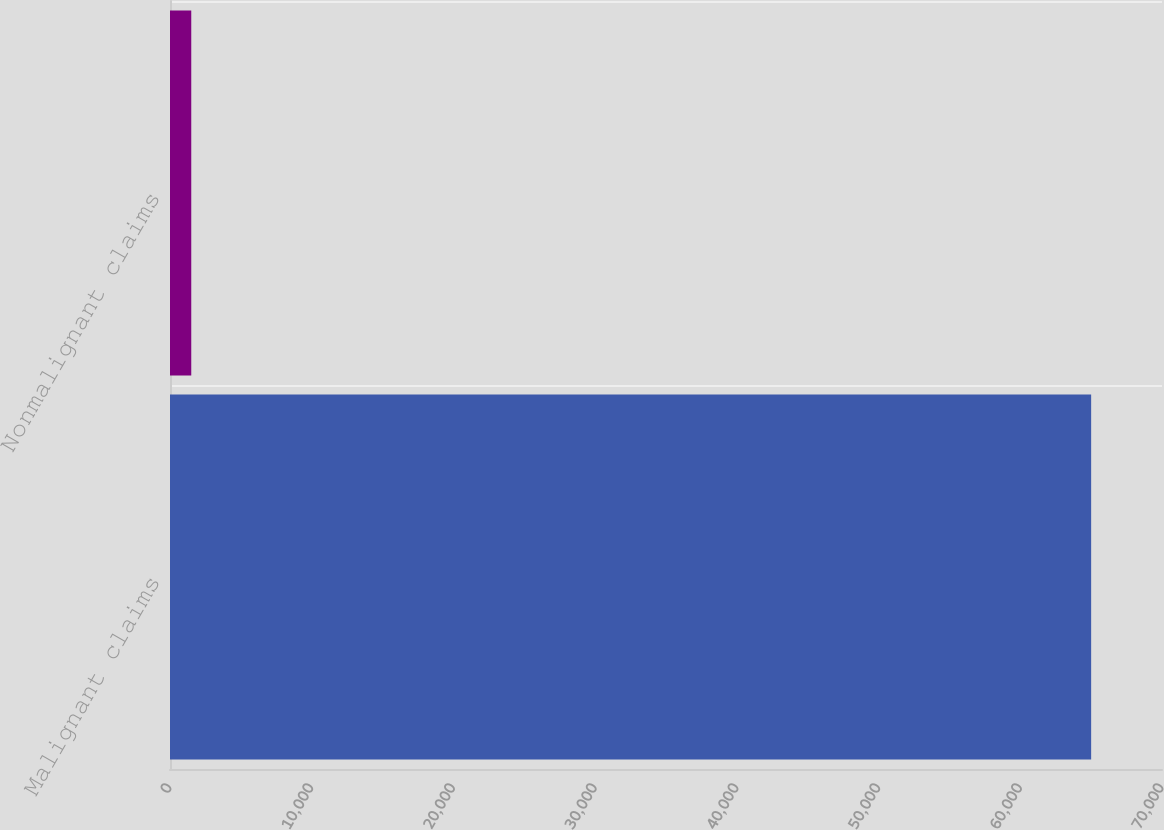Convert chart. <chart><loc_0><loc_0><loc_500><loc_500><bar_chart><fcel>Malignant claims<fcel>Nonmalignant claims<nl><fcel>65000<fcel>1500<nl></chart> 